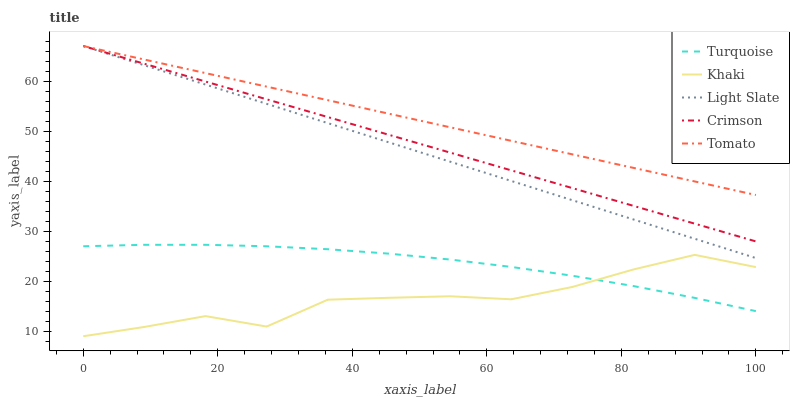Does Khaki have the minimum area under the curve?
Answer yes or no. Yes. Does Tomato have the maximum area under the curve?
Answer yes or no. Yes. Does Crimson have the minimum area under the curve?
Answer yes or no. No. Does Crimson have the maximum area under the curve?
Answer yes or no. No. Is Light Slate the smoothest?
Answer yes or no. Yes. Is Khaki the roughest?
Answer yes or no. Yes. Is Crimson the smoothest?
Answer yes or no. No. Is Crimson the roughest?
Answer yes or no. No. Does Khaki have the lowest value?
Answer yes or no. Yes. Does Crimson have the lowest value?
Answer yes or no. No. Does Tomato have the highest value?
Answer yes or no. Yes. Does Turquoise have the highest value?
Answer yes or no. No. Is Turquoise less than Crimson?
Answer yes or no. Yes. Is Crimson greater than Turquoise?
Answer yes or no. Yes. Does Light Slate intersect Tomato?
Answer yes or no. Yes. Is Light Slate less than Tomato?
Answer yes or no. No. Is Light Slate greater than Tomato?
Answer yes or no. No. Does Turquoise intersect Crimson?
Answer yes or no. No. 